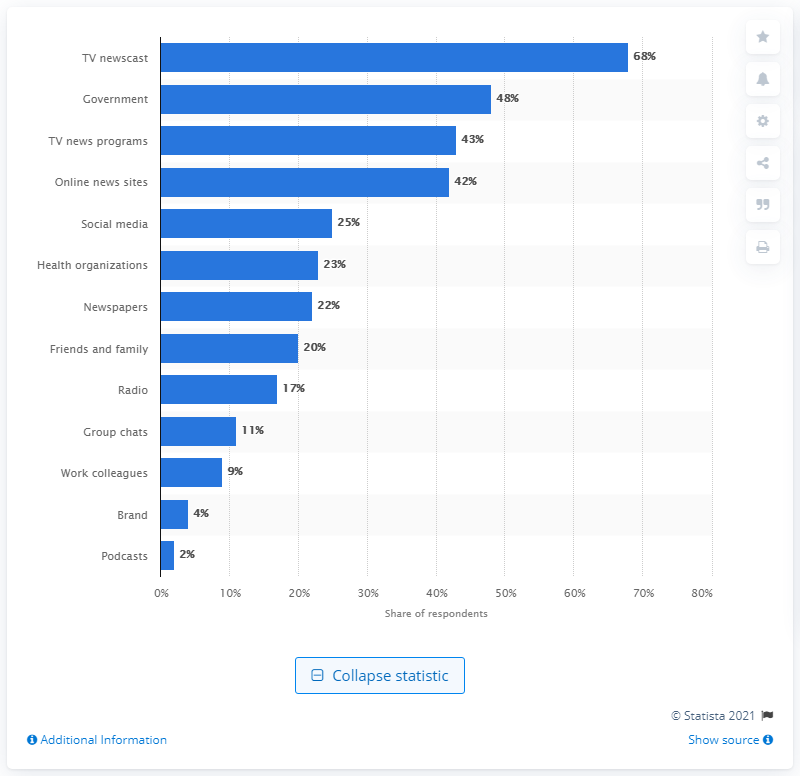Highlight a few significant elements in this photo. In Italy, the most trustworthy news source was found to be television news broadcasts. 